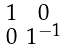Convert formula to latex. <formula><loc_0><loc_0><loc_500><loc_500>\begin{smallmatrix} { 1 } & 0 \\ 0 & { 1 } ^ { - 1 } \end{smallmatrix}</formula> 